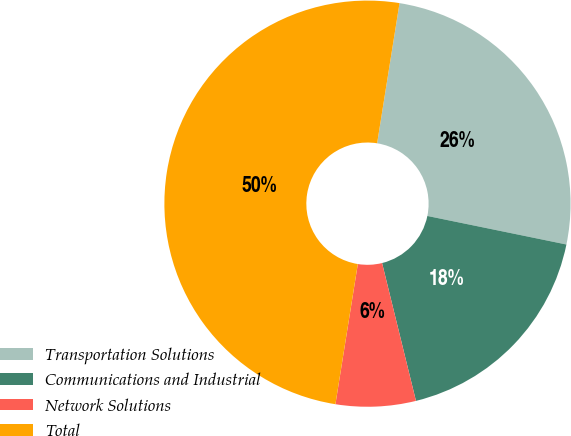Convert chart. <chart><loc_0><loc_0><loc_500><loc_500><pie_chart><fcel>Transportation Solutions<fcel>Communications and Industrial<fcel>Network Solutions<fcel>Total<nl><fcel>25.7%<fcel>17.94%<fcel>6.36%<fcel>50.0%<nl></chart> 